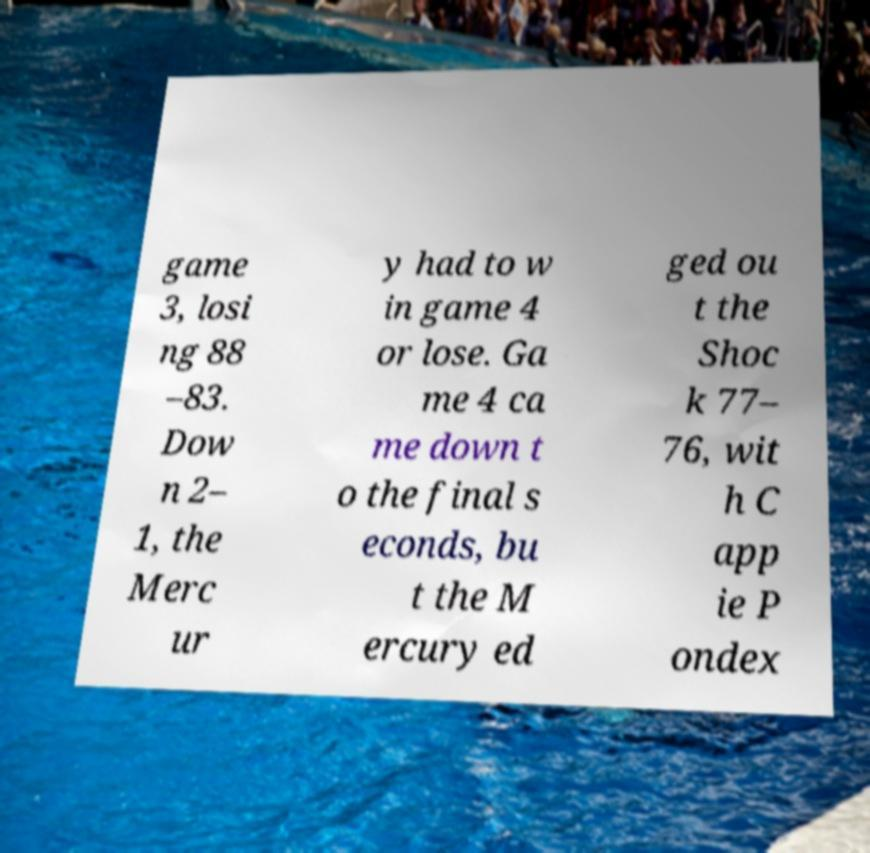Could you extract and type out the text from this image? game 3, losi ng 88 –83. Dow n 2– 1, the Merc ur y had to w in game 4 or lose. Ga me 4 ca me down t o the final s econds, bu t the M ercury ed ged ou t the Shoc k 77– 76, wit h C app ie P ondex 